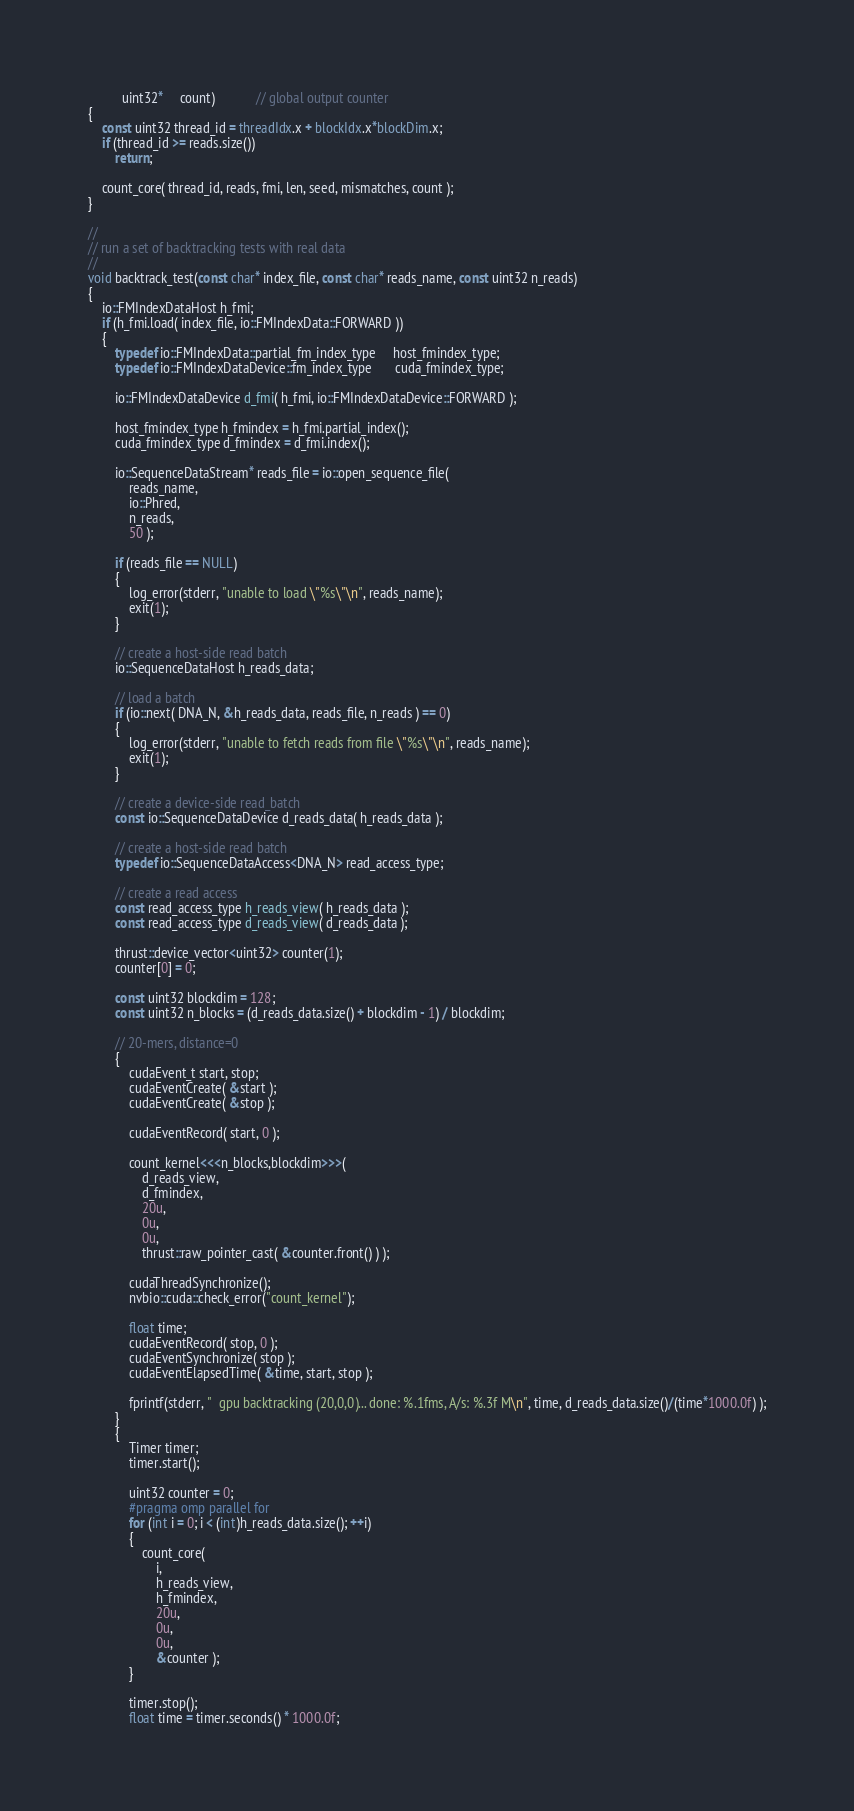<code> <loc_0><loc_0><loc_500><loc_500><_Cuda_>          uint32*     count)            // global output counter
{
    const uint32 thread_id = threadIdx.x + blockIdx.x*blockDim.x;
    if (thread_id >= reads.size())
        return;

    count_core( thread_id, reads, fmi, len, seed, mismatches, count );
}

//
// run a set of backtracking tests with real data
//
void backtrack_test(const char* index_file, const char* reads_name, const uint32 n_reads)
{
    io::FMIndexDataHost h_fmi;
    if (h_fmi.load( index_file, io::FMIndexData::FORWARD ))
    {
        typedef io::FMIndexData::partial_fm_index_type     host_fmindex_type;
        typedef io::FMIndexDataDevice::fm_index_type       cuda_fmindex_type;

        io::FMIndexDataDevice d_fmi( h_fmi, io::FMIndexDataDevice::FORWARD );

        host_fmindex_type h_fmindex = h_fmi.partial_index();
        cuda_fmindex_type d_fmindex = d_fmi.index();

        io::SequenceDataStream* reads_file = io::open_sequence_file(
            reads_name,
            io::Phred,
            n_reads,
            50 );

        if (reads_file == NULL)
        {
            log_error(stderr, "unable to load \"%s\"\n", reads_name);
            exit(1);
        }

        // create a host-side read batch
        io::SequenceDataHost h_reads_data;

        // load a batch
        if (io::next( DNA_N, &h_reads_data, reads_file, n_reads ) == 0)
        {
            log_error(stderr, "unable to fetch reads from file \"%s\"\n", reads_name);
            exit(1);
        }

        // create a device-side read_batch
        const io::SequenceDataDevice d_reads_data( h_reads_data );

        // create a host-side read batch
        typedef io::SequenceDataAccess<DNA_N> read_access_type;

        // create a read access
        const read_access_type h_reads_view( h_reads_data );
        const read_access_type d_reads_view( d_reads_data );

        thrust::device_vector<uint32> counter(1);
        counter[0] = 0;

        const uint32 blockdim = 128;
        const uint32 n_blocks = (d_reads_data.size() + blockdim - 1) / blockdim;

        // 20-mers, distance=0
        {
            cudaEvent_t start, stop;
            cudaEventCreate( &start );
            cudaEventCreate( &stop );

            cudaEventRecord( start, 0 );

            count_kernel<<<n_blocks,blockdim>>>(
                d_reads_view,
                d_fmindex,
                20u,
                0u,
                0u,
                thrust::raw_pointer_cast( &counter.front() ) );

            cudaThreadSynchronize();
            nvbio::cuda::check_error("count_kernel");

            float time;
            cudaEventRecord( stop, 0 );
            cudaEventSynchronize( stop );
            cudaEventElapsedTime( &time, start, stop );

            fprintf(stderr, "  gpu backtracking (20,0,0)... done: %.1fms, A/s: %.3f M\n", time, d_reads_data.size()/(time*1000.0f) );
        }
        {
            Timer timer;
            timer.start();

            uint32 counter = 0;
            #pragma omp parallel for
            for (int i = 0; i < (int)h_reads_data.size(); ++i)
            {
                count_core(
                    i,
                    h_reads_view,
                    h_fmindex,
                    20u,
                    0u,
                    0u,
                    &counter );
            }

            timer.stop();
            float time = timer.seconds() * 1000.0f;
</code> 